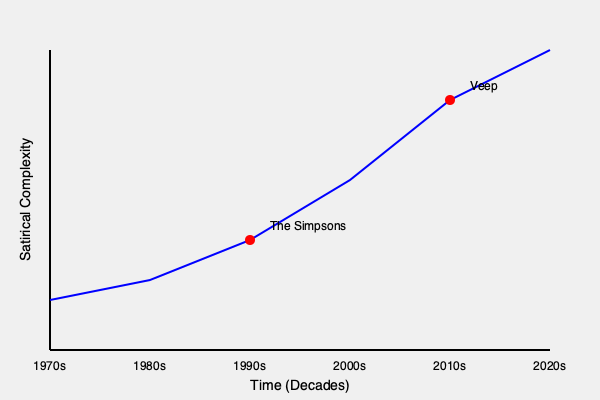Analyze the evolution of political satire in TV shows from the 1970s to the 2020s, as depicted in the graph. How do the character archetypes and plot structures of "The Simpsons" and "Veep" reflect this progression, and what factors contributed to the increasing complexity of satirical content over time? 1. Trend Analysis:
   The graph shows a clear upward trend in satirical complexity from the 1970s to the 2020s, indicating that political satire in TV shows has become more sophisticated over time.

2. The Simpsons (1990s):
   a) Character Archetypes: Introduced layered characters like Homer Simpson, representing the average American, and Mr. Burns, symbolizing corporate greed.
   b) Plot Structures: Episodic format allowed for tackling various political issues without deep continuity.
   c) Satire Level: Marked a significant increase in satirical complexity, using irony and exaggeration to comment on American politics and society.

3. Veep (2010s):
   a) Character Archetypes: Developed more nuanced characters like Selina Meyer, showcasing the complexities of political ambition and public service.
   b) Plot Structures: Serialized storytelling allowed for intricate, long-term political narratives and character development.
   c) Satire Level: Represented a peak in satirical complexity, using sharp dialogue and cynical portrayals of political processes.

4. Factors Contributing to Increased Complexity:
   a) Political Climate: Growing political polarization and global issues provided more material for satire.
   b) Media Landscape: The rise of cable news and social media increased political awareness and discourse.
   c) Audience Sophistication: Viewers became more politically savvy, demanding more intricate satire.
   d) Creative Freedom: Cable and streaming platforms allowed for bolder, less censored content.

5. Evolution of Satirical Techniques:
   a) 1970s-1980s: More straightforward, often slapstick political humor (e.g., "All in the Family").
   b) 1990s-2000s: Increased use of irony and social commentary (e.g., "The Simpsons," "South Park").
   c) 2010s-2020s: Highly nuanced, often dark political satire (e.g., "Veep," "Black Mirror").

The progression from "The Simpsons" to "Veep" demonstrates how political satire evolved from broad, accessible commentary to intricate, insider-focused critique, reflecting the overall trend of increasing satirical complexity in TV shows over the past five decades.
Answer: Increased political awareness, media evolution, and audience sophistication led to more complex character archetypes and plot structures, evolving from broad commentary in "The Simpsons" to intricate political critique in "Veep." 